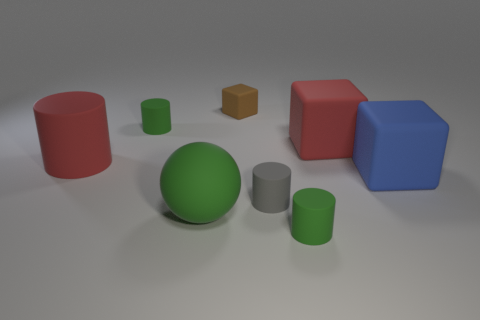Is there a object of the same color as the big cylinder?
Your answer should be very brief. Yes. There is a large cube that is to the left of the large blue matte thing; is it the same color as the large object left of the green rubber sphere?
Your answer should be compact. Yes. The block that is the same size as the gray object is what color?
Keep it short and to the point. Brown. How many other things are there of the same shape as the tiny gray matte object?
Your response must be concise. 3. Is there a large blue cube made of the same material as the blue object?
Make the answer very short. No. Does the cube that is to the left of the red rubber cube have the same material as the large red thing that is left of the big green rubber sphere?
Your response must be concise. Yes. How many large matte cubes are there?
Ensure brevity in your answer.  2. What shape is the gray thing in front of the tiny brown rubber thing?
Offer a very short reply. Cylinder. Is the shape of the big matte object to the left of the large green thing the same as the red object to the right of the tiny brown matte block?
Make the answer very short. No. How many red cylinders are to the right of the large blue matte object?
Keep it short and to the point. 0. 